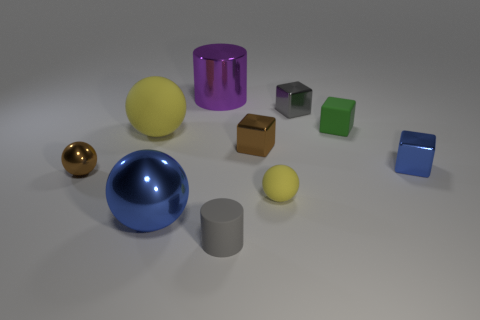Subtract all tiny metal cubes. How many cubes are left? 1 Subtract 1 blocks. How many blocks are left? 3 Subtract all brown spheres. How many spheres are left? 3 Subtract all cylinders. How many objects are left? 8 Subtract all gray blocks. Subtract all purple spheres. How many blocks are left? 3 Subtract all gray cubes. How many blue balls are left? 1 Subtract all yellow rubber things. Subtract all small metal cubes. How many objects are left? 5 Add 4 big spheres. How many big spheres are left? 6 Add 3 tiny gray cylinders. How many tiny gray cylinders exist? 4 Subtract 0 cyan cubes. How many objects are left? 10 